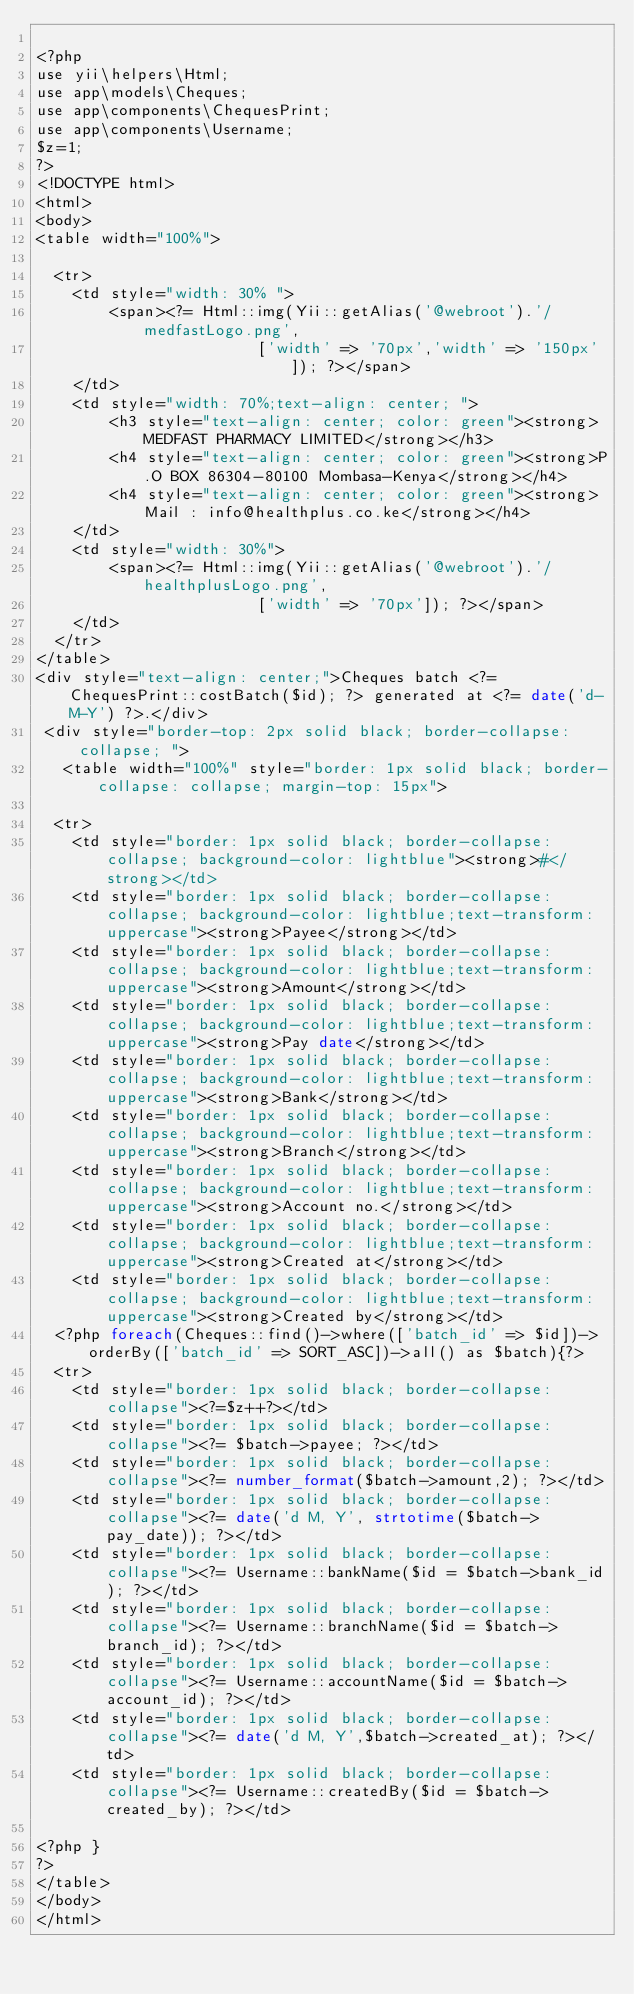Convert code to text. <code><loc_0><loc_0><loc_500><loc_500><_PHP_>
<?php
use yii\helpers\Html;
use app\models\Cheques;
use app\components\ChequesPrint;
use app\components\Username;
$z=1;
?>
<!DOCTYPE html>
<html>
<body>
<table width="100%">

  <tr>
    <td style="width: 30% ">
        <span><?= Html::img(Yii::getAlias('@webroot').'/medfastLogo.png',
                        ['width' => '70px','width' => '150px']); ?></span>
    </td>
    <td style="width: 70%;text-align: center; ">
        <h3 style="text-align: center; color: green"><strong>MEDFAST PHARMACY LIMITED</strong></h3>
        <h4 style="text-align: center; color: green"><strong>P.O BOX 86304-80100 Mombasa-Kenya</strong></h4>
        <h4 style="text-align: center; color: green"><strong>Mail : info@healthplus.co.ke</strong></h4>
    </td>
    <td style="width: 30%">
        <span><?= Html::img(Yii::getAlias('@webroot').'/healthplusLogo.png',
                        ['width' => '70px']); ?></span>
    </td>
  </tr>
</table>
<div style="text-align: center;">Cheques batch <?= ChequesPrint::costBatch($id); ?> generated at <?= date('d-M-Y') ?>.</div>
 <div style="border-top: 2px solid black; border-collapse: collapse; ">
   <table width="100%" style="border: 1px solid black; border-collapse: collapse; margin-top: 15px">

  <tr>
    <td style="border: 1px solid black; border-collapse: collapse; background-color: lightblue"><strong>#</strong></td>
    <td style="border: 1px solid black; border-collapse: collapse; background-color: lightblue;text-transform: uppercase"><strong>Payee</strong></td>
    <td style="border: 1px solid black; border-collapse: collapse; background-color: lightblue;text-transform: uppercase"><strong>Amount</strong></td>
    <td style="border: 1px solid black; border-collapse: collapse; background-color: lightblue;text-transform: uppercase"><strong>Pay date</strong></td>
    <td style="border: 1px solid black; border-collapse: collapse; background-color: lightblue;text-transform: uppercase"><strong>Bank</strong></td>
    <td style="border: 1px solid black; border-collapse: collapse; background-color: lightblue;text-transform: uppercase"><strong>Branch</strong></td>
    <td style="border: 1px solid black; border-collapse: collapse; background-color: lightblue;text-transform: uppercase"><strong>Account no.</strong></td>
    <td style="border: 1px solid black; border-collapse: collapse; background-color: lightblue;text-transform: uppercase"><strong>Created at</strong></td>
    <td style="border: 1px solid black; border-collapse: collapse; background-color: lightblue;text-transform: uppercase"><strong>Created by</strong></td>
  <?php foreach(Cheques::find()->where(['batch_id' => $id])->orderBy(['batch_id' => SORT_ASC])->all() as $batch){?>
  <tr>
    <td style="border: 1px solid black; border-collapse: collapse"><?=$z++?></td>
    <td style="border: 1px solid black; border-collapse: collapse"><?= $batch->payee; ?></td>
    <td style="border: 1px solid black; border-collapse: collapse"><?= number_format($batch->amount,2); ?></td>
    <td style="border: 1px solid black; border-collapse: collapse"><?= date('d M, Y', strtotime($batch->pay_date)); ?></td>
    <td style="border: 1px solid black; border-collapse: collapse"><?= Username::bankName($id = $batch->bank_id); ?></td>
    <td style="border: 1px solid black; border-collapse: collapse"><?= Username::branchName($id = $batch->branch_id); ?></td>
    <td style="border: 1px solid black; border-collapse: collapse"><?= Username::accountName($id = $batch->account_id); ?></td>
    <td style="border: 1px solid black; border-collapse: collapse"><?= date('d M, Y',$batch->created_at); ?></td>
    <td style="border: 1px solid black; border-collapse: collapse"><?= Username::createdBy($id = $batch->created_by); ?></td>

<?php }  
?>
</table> 
</body>
</html>

</code> 